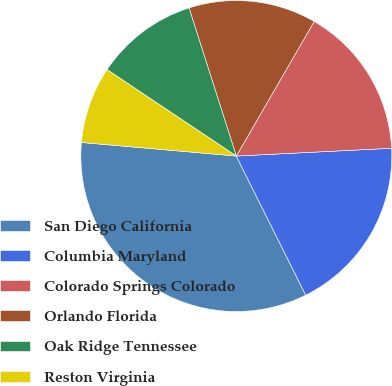<chart> <loc_0><loc_0><loc_500><loc_500><pie_chart><fcel>San Diego California<fcel>Columbia Maryland<fcel>Colorado Springs Colorado<fcel>Orlando Florida<fcel>Oak Ridge Tennessee<fcel>Reston Virginia<nl><fcel>33.76%<fcel>18.43%<fcel>15.85%<fcel>13.27%<fcel>10.7%<fcel>7.99%<nl></chart> 